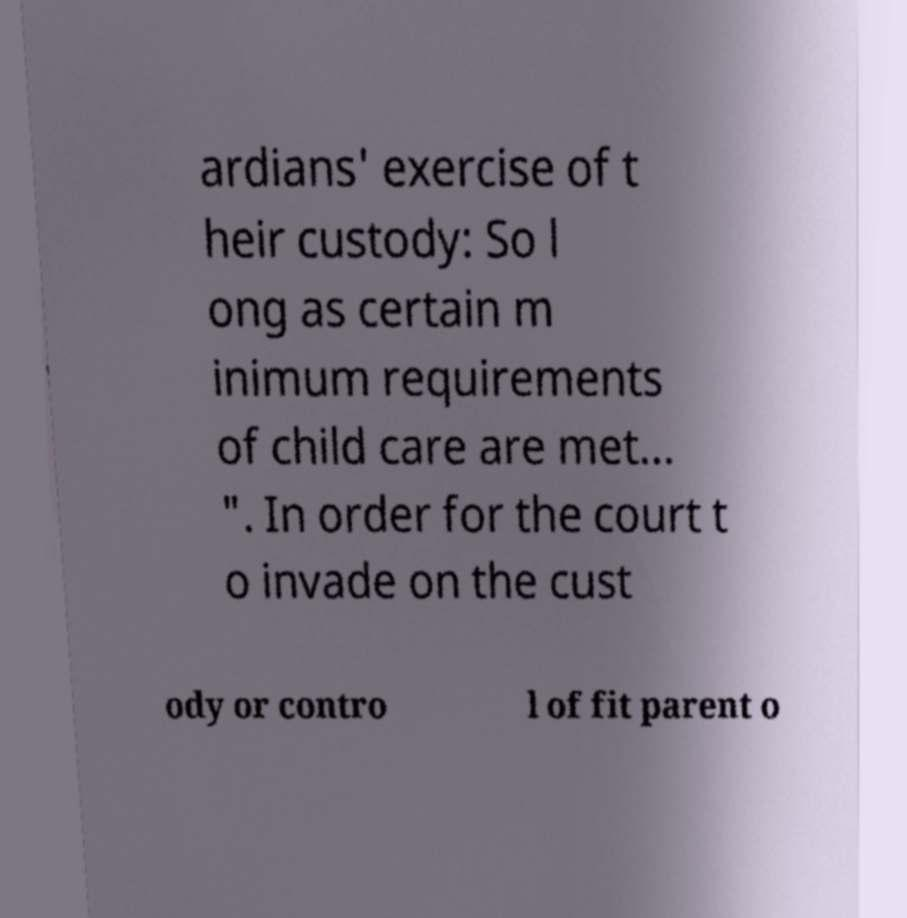For documentation purposes, I need the text within this image transcribed. Could you provide that? ardians' exercise of t heir custody: So l ong as certain m inimum requirements of child care are met... ". In order for the court t o invade on the cust ody or contro l of fit parent o 